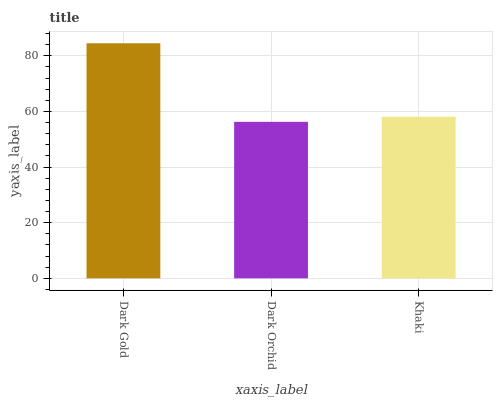Is Khaki the minimum?
Answer yes or no. No. Is Khaki the maximum?
Answer yes or no. No. Is Khaki greater than Dark Orchid?
Answer yes or no. Yes. Is Dark Orchid less than Khaki?
Answer yes or no. Yes. Is Dark Orchid greater than Khaki?
Answer yes or no. No. Is Khaki less than Dark Orchid?
Answer yes or no. No. Is Khaki the high median?
Answer yes or no. Yes. Is Khaki the low median?
Answer yes or no. Yes. Is Dark Orchid the high median?
Answer yes or no. No. Is Dark Orchid the low median?
Answer yes or no. No. 